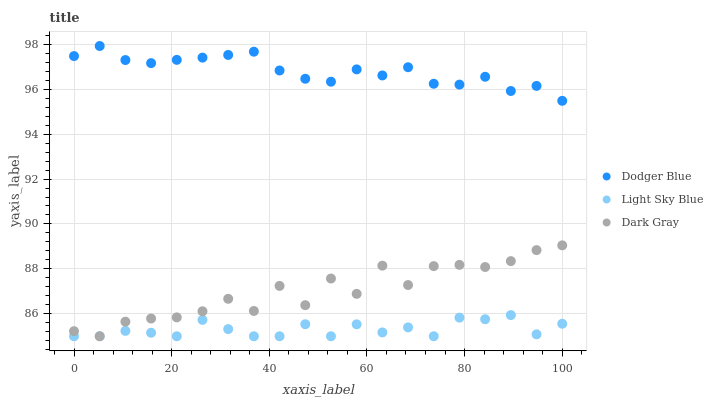Does Light Sky Blue have the minimum area under the curve?
Answer yes or no. Yes. Does Dodger Blue have the maximum area under the curve?
Answer yes or no. Yes. Does Dodger Blue have the minimum area under the curve?
Answer yes or no. No. Does Light Sky Blue have the maximum area under the curve?
Answer yes or no. No. Is Dodger Blue the smoothest?
Answer yes or no. Yes. Is Dark Gray the roughest?
Answer yes or no. Yes. Is Light Sky Blue the smoothest?
Answer yes or no. No. Is Light Sky Blue the roughest?
Answer yes or no. No. Does Dark Gray have the lowest value?
Answer yes or no. Yes. Does Dodger Blue have the lowest value?
Answer yes or no. No. Does Dodger Blue have the highest value?
Answer yes or no. Yes. Does Light Sky Blue have the highest value?
Answer yes or no. No. Is Dark Gray less than Dodger Blue?
Answer yes or no. Yes. Is Dodger Blue greater than Dark Gray?
Answer yes or no. Yes. Does Dark Gray intersect Light Sky Blue?
Answer yes or no. Yes. Is Dark Gray less than Light Sky Blue?
Answer yes or no. No. Is Dark Gray greater than Light Sky Blue?
Answer yes or no. No. Does Dark Gray intersect Dodger Blue?
Answer yes or no. No. 